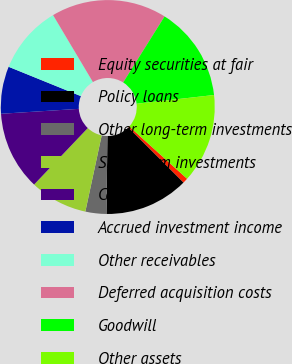Convert chart. <chart><loc_0><loc_0><loc_500><loc_500><pie_chart><fcel>Equity securities at fair<fcel>Policy loans<fcel>Other long-term investments<fcel>Short-term investments<fcel>Cash<fcel>Accrued investment income<fcel>Other receivables<fcel>Deferred acquisition costs<fcel>Goodwill<fcel>Other assets<nl><fcel>0.79%<fcel>12.7%<fcel>3.17%<fcel>8.73%<fcel>11.9%<fcel>7.14%<fcel>10.32%<fcel>17.46%<fcel>14.29%<fcel>13.49%<nl></chart> 